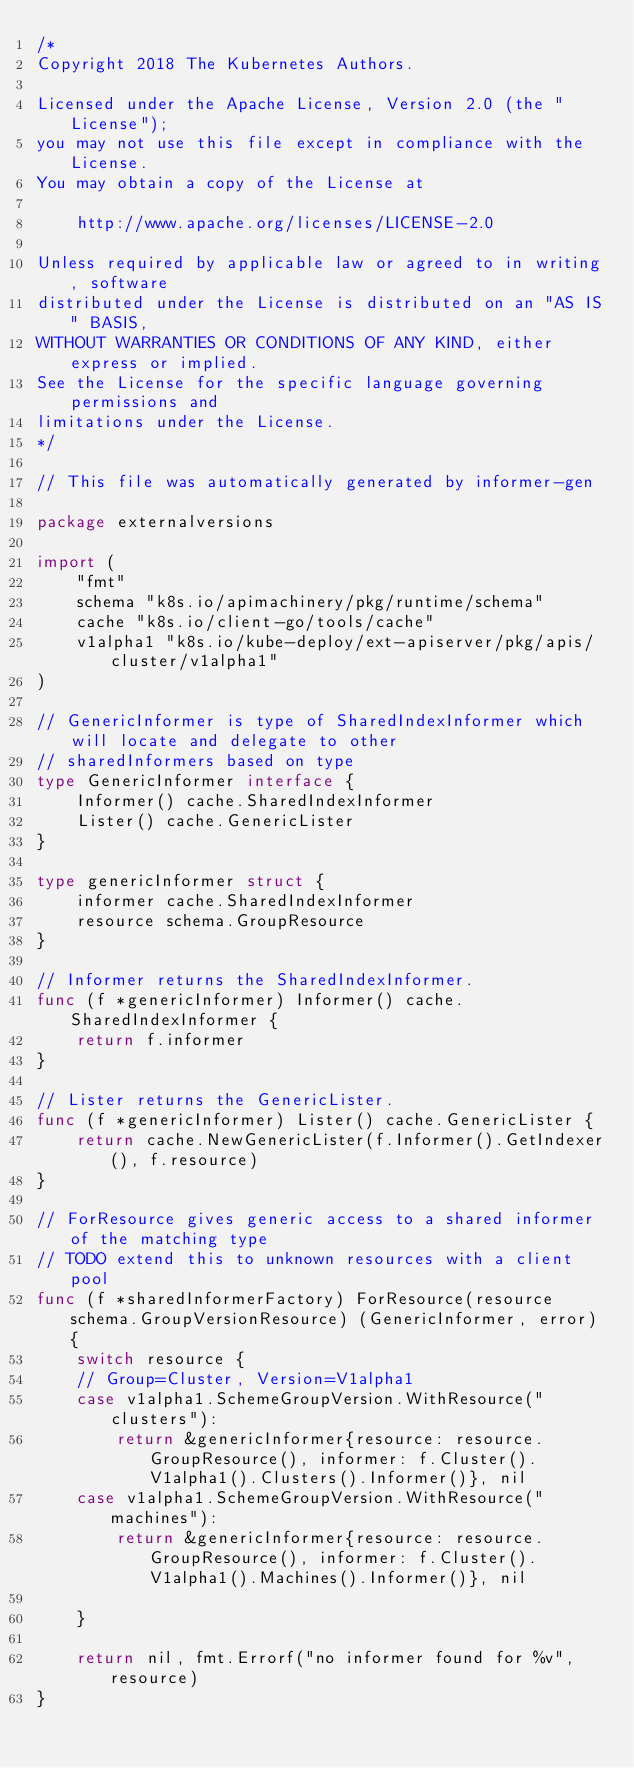<code> <loc_0><loc_0><loc_500><loc_500><_Go_>/*
Copyright 2018 The Kubernetes Authors.

Licensed under the Apache License, Version 2.0 (the "License");
you may not use this file except in compliance with the License.
You may obtain a copy of the License at

    http://www.apache.org/licenses/LICENSE-2.0

Unless required by applicable law or agreed to in writing, software
distributed under the License is distributed on an "AS IS" BASIS,
WITHOUT WARRANTIES OR CONDITIONS OF ANY KIND, either express or implied.
See the License for the specific language governing permissions and
limitations under the License.
*/

// This file was automatically generated by informer-gen

package externalversions

import (
	"fmt"
	schema "k8s.io/apimachinery/pkg/runtime/schema"
	cache "k8s.io/client-go/tools/cache"
	v1alpha1 "k8s.io/kube-deploy/ext-apiserver/pkg/apis/cluster/v1alpha1"
)

// GenericInformer is type of SharedIndexInformer which will locate and delegate to other
// sharedInformers based on type
type GenericInformer interface {
	Informer() cache.SharedIndexInformer
	Lister() cache.GenericLister
}

type genericInformer struct {
	informer cache.SharedIndexInformer
	resource schema.GroupResource
}

// Informer returns the SharedIndexInformer.
func (f *genericInformer) Informer() cache.SharedIndexInformer {
	return f.informer
}

// Lister returns the GenericLister.
func (f *genericInformer) Lister() cache.GenericLister {
	return cache.NewGenericLister(f.Informer().GetIndexer(), f.resource)
}

// ForResource gives generic access to a shared informer of the matching type
// TODO extend this to unknown resources with a client pool
func (f *sharedInformerFactory) ForResource(resource schema.GroupVersionResource) (GenericInformer, error) {
	switch resource {
	// Group=Cluster, Version=V1alpha1
	case v1alpha1.SchemeGroupVersion.WithResource("clusters"):
		return &genericInformer{resource: resource.GroupResource(), informer: f.Cluster().V1alpha1().Clusters().Informer()}, nil
	case v1alpha1.SchemeGroupVersion.WithResource("machines"):
		return &genericInformer{resource: resource.GroupResource(), informer: f.Cluster().V1alpha1().Machines().Informer()}, nil

	}

	return nil, fmt.Errorf("no informer found for %v", resource)
}
</code> 